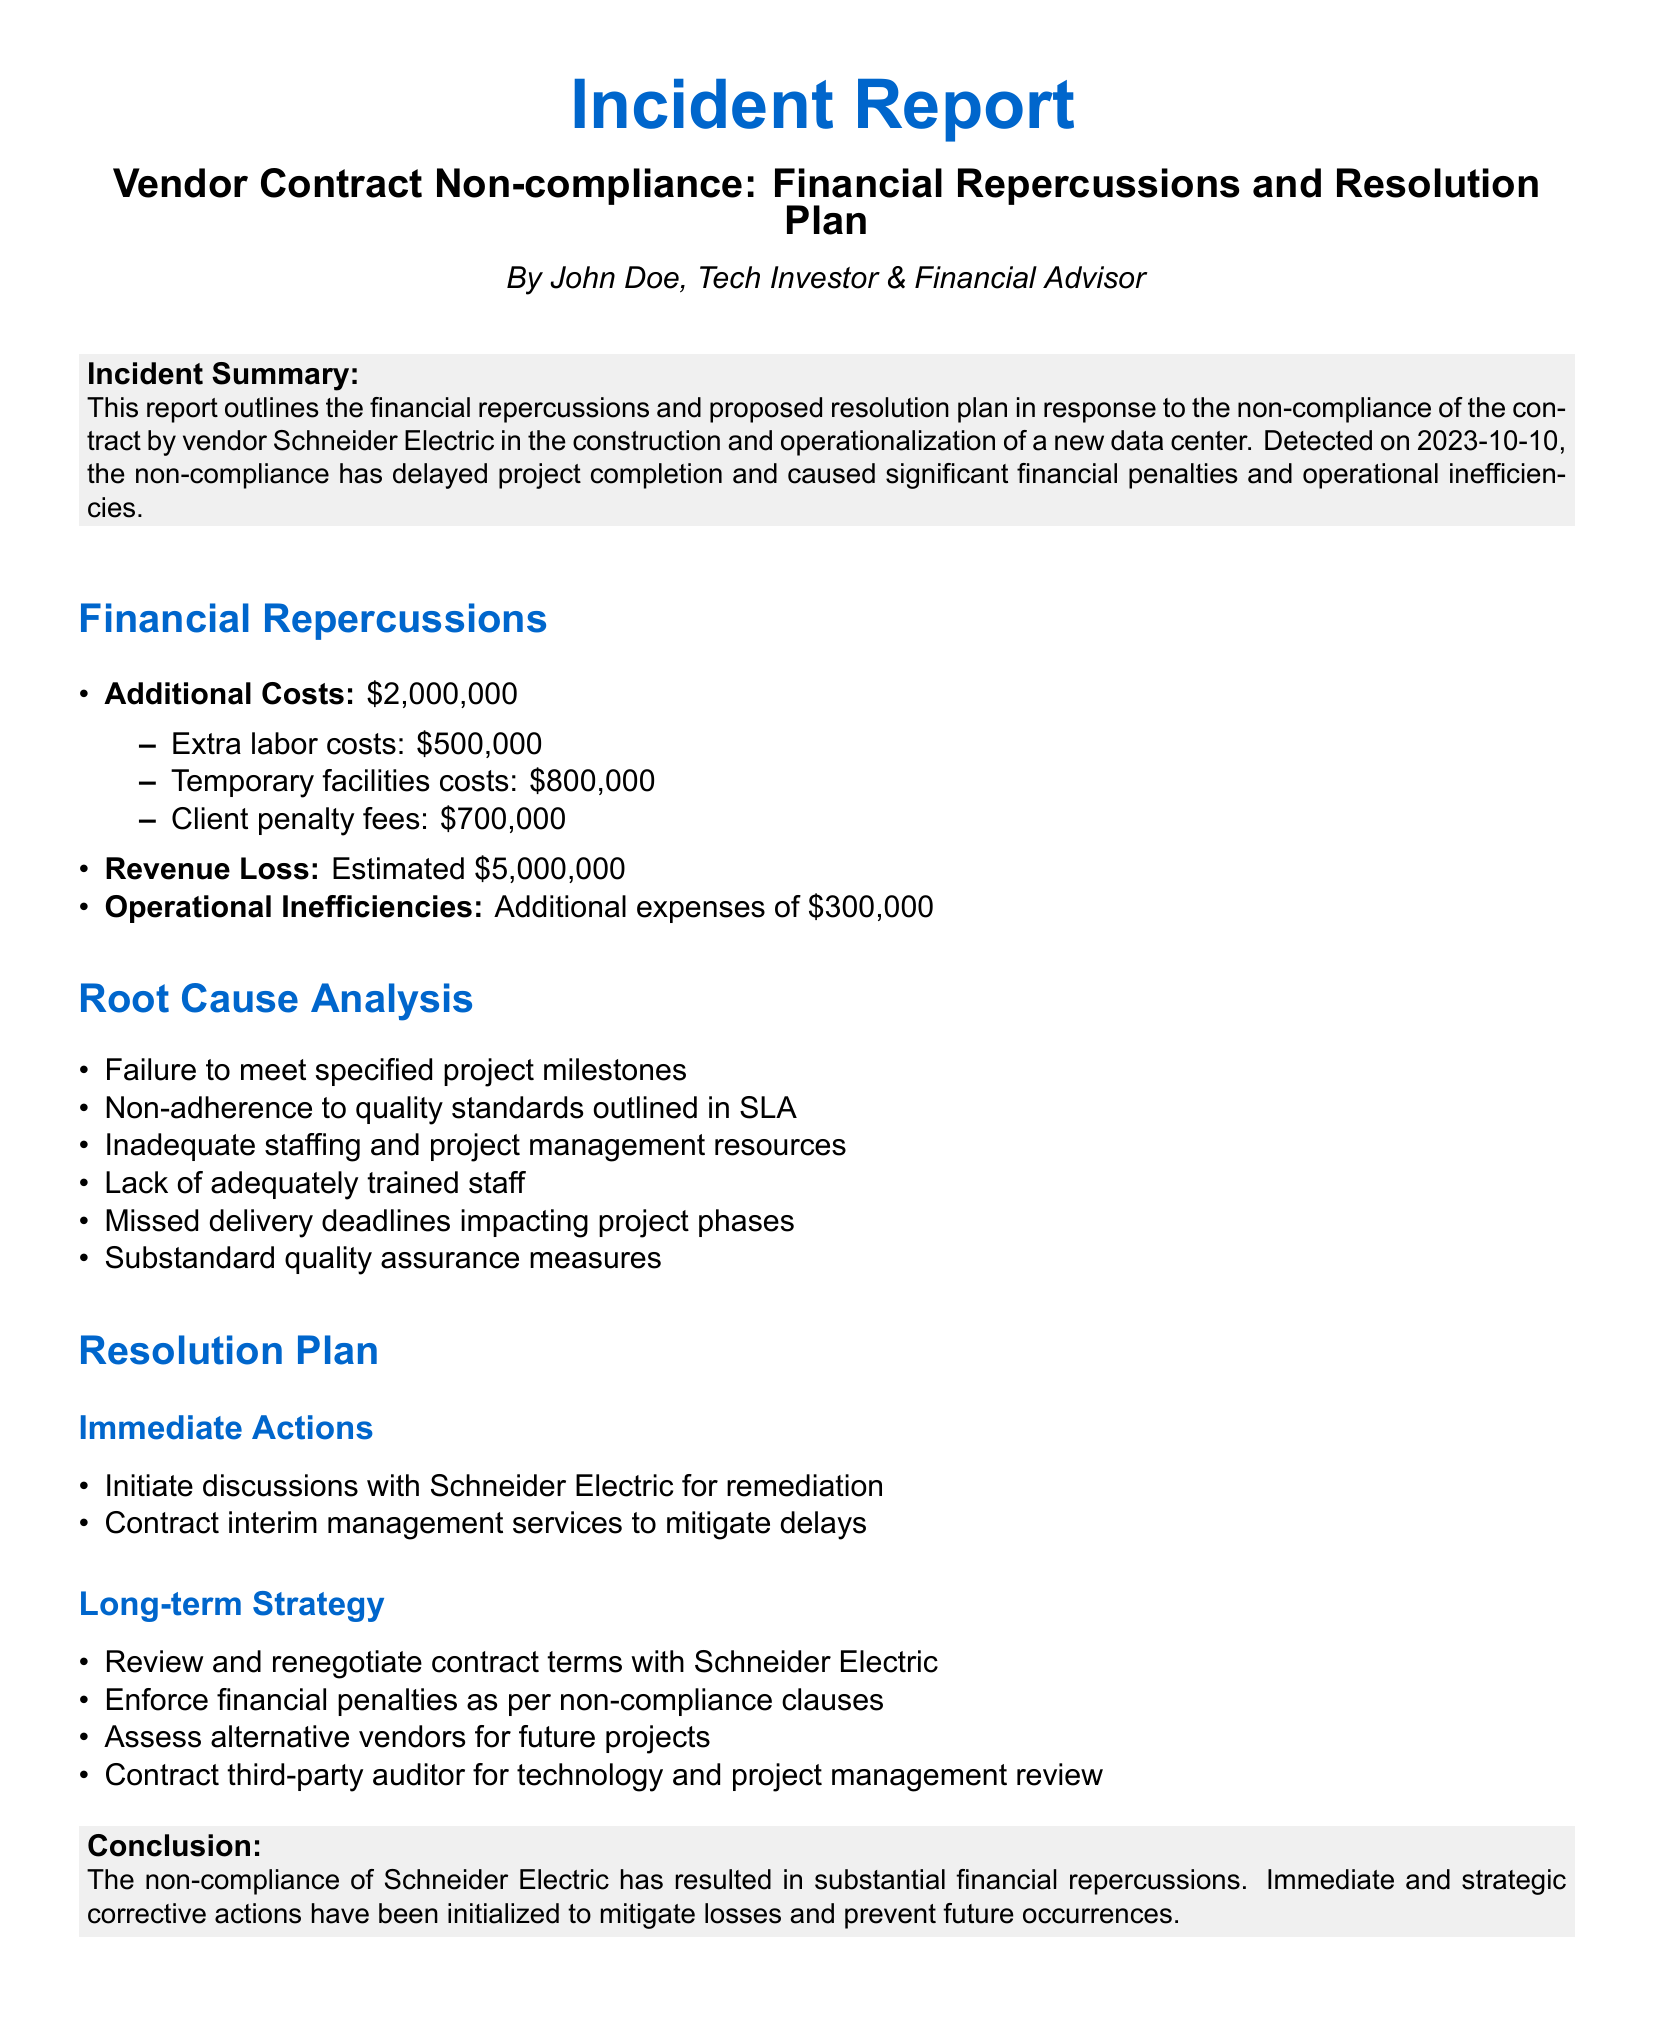What is the title of the incident report? The title of the incident report is provided at the top of the document, summarizing the issue with the vendor.
Answer: Vendor Contract Non-compliance: Financial Repercussions and Resolution Plan On what date was the non-compliance detected? The document states the detection date of the non-compliance in the incident summary section.
Answer: 2023-10-10 What is the total additional cost incurred due to non-compliance? The document lists the additional costs associated with non-compliance, which can be summed up.
Answer: $2,000,000 What is the estimated revenue loss reported? The estimated revenue loss is directly mentioned in the financial repercussions section of the document.
Answer: Estimated $5,000,000 What are the immediate actions proposed in the resolution plan? The resolution plan section details the immediate actions to address the issue.
Answer: Initiate discussions with Schneider Electric for remediation, Contract interim management services to mitigate delays What is one root cause of the vendor's non-compliance? The root cause analysis lists several reasons, and one of them can be easily identified.
Answer: Failure to meet specified project milestones What is one part of the long-term strategy to prevent future occurrences? The long-term strategy section outlines systematic approaches to address the future risk of non-compliance.
Answer: Review and renegotiate contract terms with Schneider Electric How much are the client penalty fees reported in the additional costs? The document provides a specific breakdown of the additional costs, including client penalty fees.
Answer: $700,000 What role does the third-party auditor play according to the resolution plan? The long-term strategy mentions the involvement of a third-party auditor in evaluating project management.
Answer: Contract third-party auditor for technology and project management review 